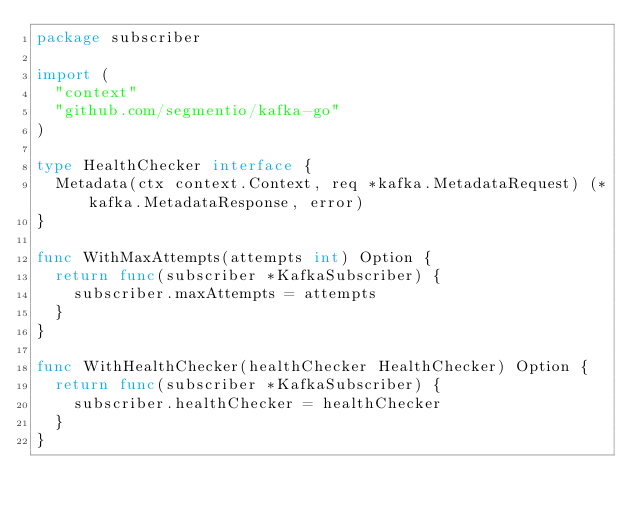<code> <loc_0><loc_0><loc_500><loc_500><_Go_>package subscriber

import (
	"context"
	"github.com/segmentio/kafka-go"
)

type HealthChecker interface {
	Metadata(ctx context.Context, req *kafka.MetadataRequest) (*kafka.MetadataResponse, error)
}

func WithMaxAttempts(attempts int) Option {
	return func(subscriber *KafkaSubscriber) {
		subscriber.maxAttempts = attempts
	}
}

func WithHealthChecker(healthChecker HealthChecker) Option {
	return func(subscriber *KafkaSubscriber) {
		subscriber.healthChecker = healthChecker
	}
}
</code> 